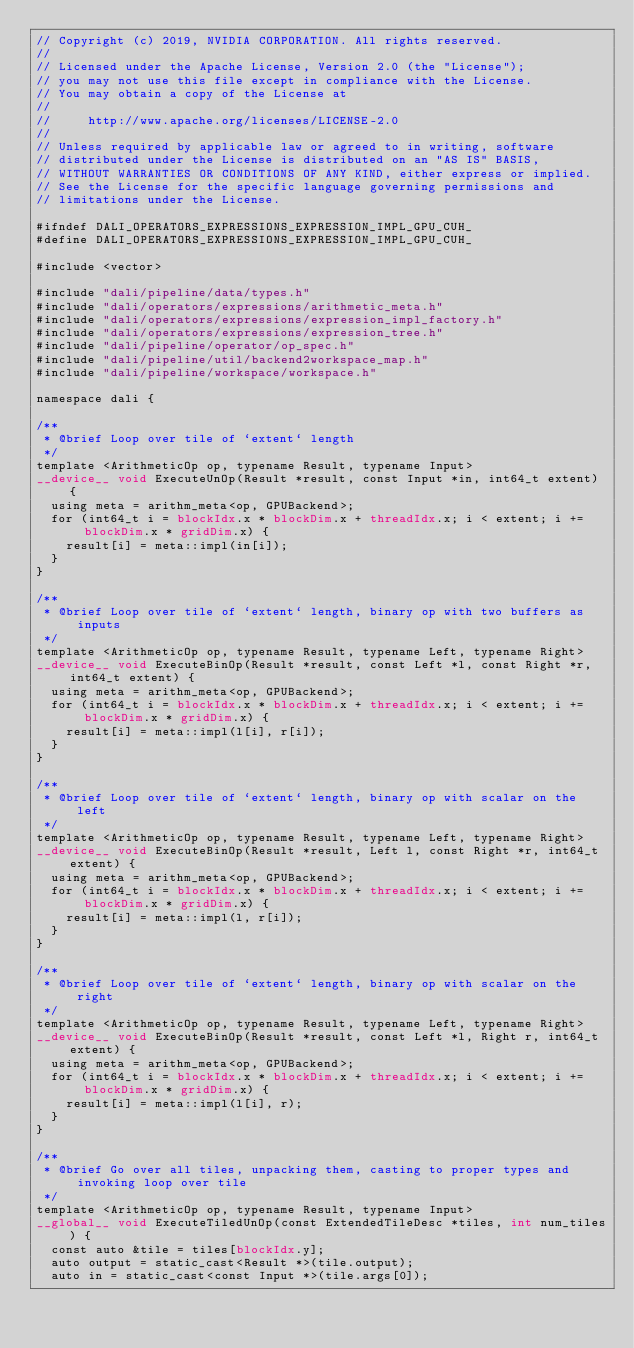<code> <loc_0><loc_0><loc_500><loc_500><_Cuda_>// Copyright (c) 2019, NVIDIA CORPORATION. All rights reserved.
//
// Licensed under the Apache License, Version 2.0 (the "License");
// you may not use this file except in compliance with the License.
// You may obtain a copy of the License at
//
//     http://www.apache.org/licenses/LICENSE-2.0
//
// Unless required by applicable law or agreed to in writing, software
// distributed under the License is distributed on an "AS IS" BASIS,
// WITHOUT WARRANTIES OR CONDITIONS OF ANY KIND, either express or implied.
// See the License for the specific language governing permissions and
// limitations under the License.

#ifndef DALI_OPERATORS_EXPRESSIONS_EXPRESSION_IMPL_GPU_CUH_
#define DALI_OPERATORS_EXPRESSIONS_EXPRESSION_IMPL_GPU_CUH_

#include <vector>

#include "dali/pipeline/data/types.h"
#include "dali/operators/expressions/arithmetic_meta.h"
#include "dali/operators/expressions/expression_impl_factory.h"
#include "dali/operators/expressions/expression_tree.h"
#include "dali/pipeline/operator/op_spec.h"
#include "dali/pipeline/util/backend2workspace_map.h"
#include "dali/pipeline/workspace/workspace.h"

namespace dali {

/**
 * @brief Loop over tile of `extent` length
 */
template <ArithmeticOp op, typename Result, typename Input>
__device__ void ExecuteUnOp(Result *result, const Input *in, int64_t extent) {
  using meta = arithm_meta<op, GPUBackend>;
  for (int64_t i = blockIdx.x * blockDim.x + threadIdx.x; i < extent; i += blockDim.x * gridDim.x) {
    result[i] = meta::impl(in[i]);
  }
}

/**
 * @brief Loop over tile of `extent` length, binary op with two buffers as inputs
 */
template <ArithmeticOp op, typename Result, typename Left, typename Right>
__device__ void ExecuteBinOp(Result *result, const Left *l, const Right *r, int64_t extent) {
  using meta = arithm_meta<op, GPUBackend>;
  for (int64_t i = blockIdx.x * blockDim.x + threadIdx.x; i < extent; i += blockDim.x * gridDim.x) {
    result[i] = meta::impl(l[i], r[i]);
  }
}

/**
 * @brief Loop over tile of `extent` length, binary op with scalar on the left
 */
template <ArithmeticOp op, typename Result, typename Left, typename Right>
__device__ void ExecuteBinOp(Result *result, Left l, const Right *r, int64_t extent) {
  using meta = arithm_meta<op, GPUBackend>;
  for (int64_t i = blockIdx.x * blockDim.x + threadIdx.x; i < extent; i += blockDim.x * gridDim.x) {
    result[i] = meta::impl(l, r[i]);
  }
}

/**
 * @brief Loop over tile of `extent` length, binary op with scalar on the right
 */
template <ArithmeticOp op, typename Result, typename Left, typename Right>
__device__ void ExecuteBinOp(Result *result, const Left *l, Right r, int64_t extent) {
  using meta = arithm_meta<op, GPUBackend>;
  for (int64_t i = blockIdx.x * blockDim.x + threadIdx.x; i < extent; i += blockDim.x * gridDim.x) {
    result[i] = meta::impl(l[i], r);
  }
}

/**
 * @brief Go over all tiles, unpacking them, casting to proper types and invoking loop over tile
 */
template <ArithmeticOp op, typename Result, typename Input>
__global__ void ExecuteTiledUnOp(const ExtendedTileDesc *tiles, int num_tiles) {
  const auto &tile = tiles[blockIdx.y];
  auto output = static_cast<Result *>(tile.output);
  auto in = static_cast<const Input *>(tile.args[0]);</code> 